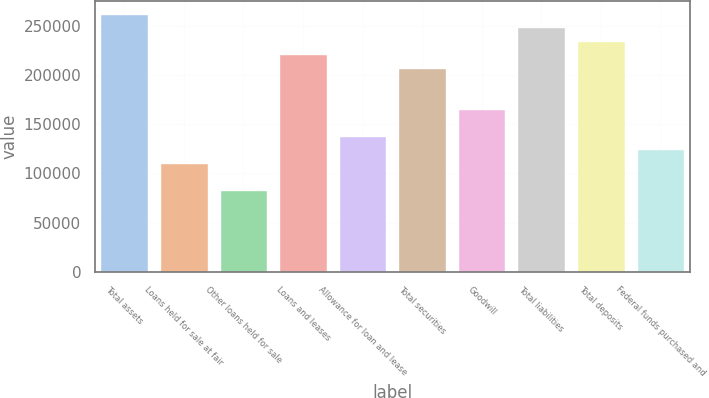<chart> <loc_0><loc_0><loc_500><loc_500><bar_chart><fcel>Total assets<fcel>Loans held for sale at fair<fcel>Other loans held for sale<fcel>Loans and leases<fcel>Allowance for loan and lease<fcel>Total securities<fcel>Goodwill<fcel>Total liabilities<fcel>Total deposits<fcel>Federal funds purchased and<nl><fcel>262594<fcel>110567<fcel>82925.2<fcel>221132<fcel>138208<fcel>207311<fcel>165849<fcel>248773<fcel>234953<fcel>124387<nl></chart> 